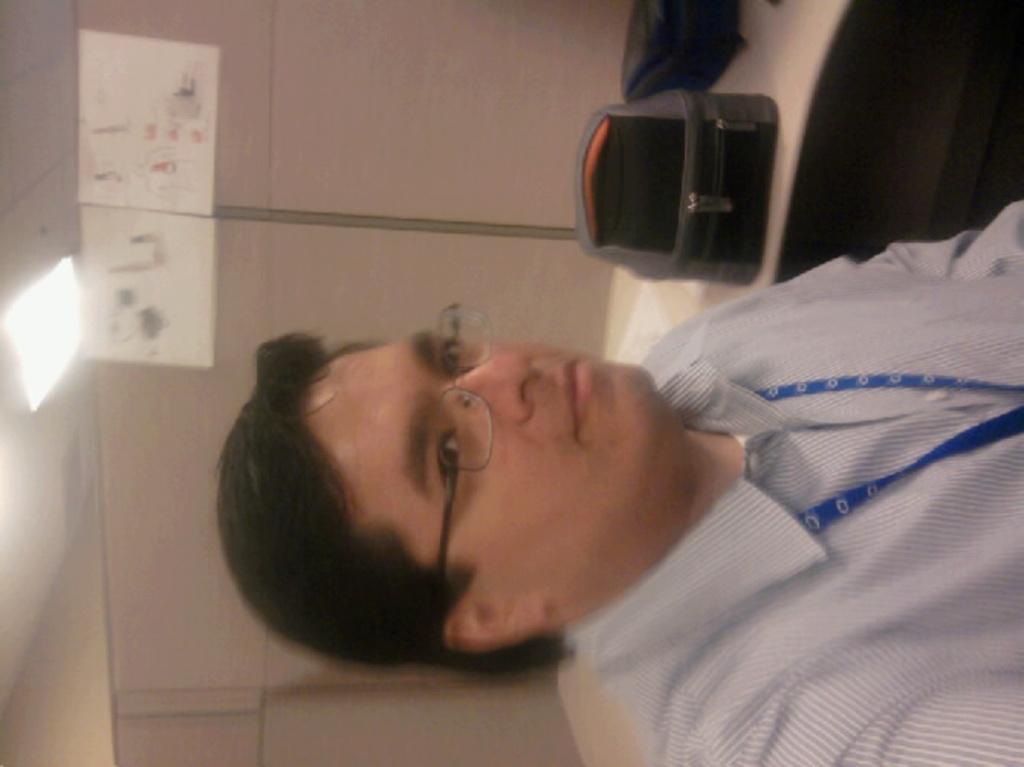Describe this image in one or two sentences. In this image I can see there is a person sitting on the chair. And beside him there is a table. On the table there is a bag. And at the back there is a cupboard and at the top there is a light. 